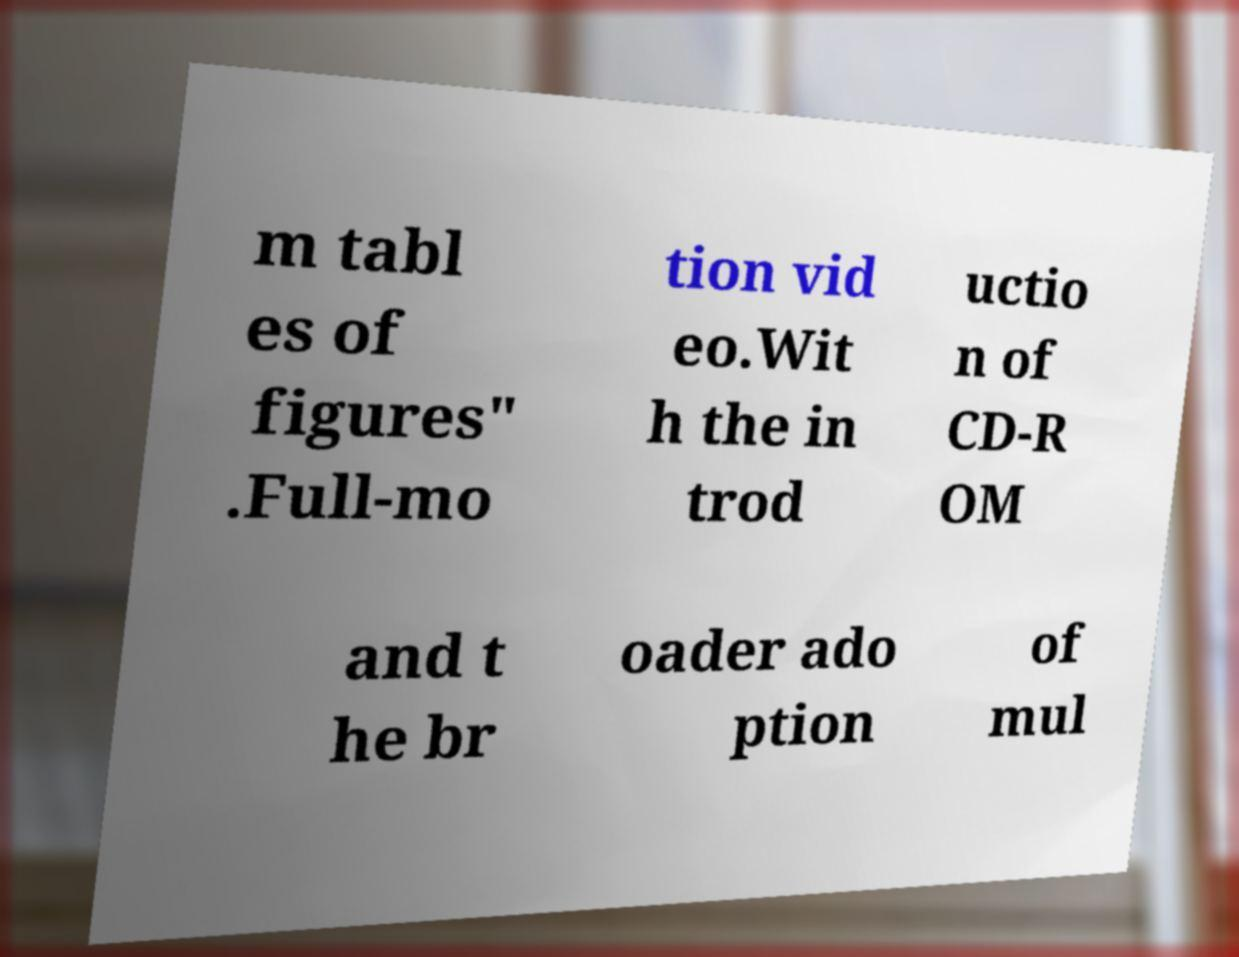Can you read and provide the text displayed in the image?This photo seems to have some interesting text. Can you extract and type it out for me? m tabl es of figures" .Full-mo tion vid eo.Wit h the in trod uctio n of CD-R OM and t he br oader ado ption of mul 